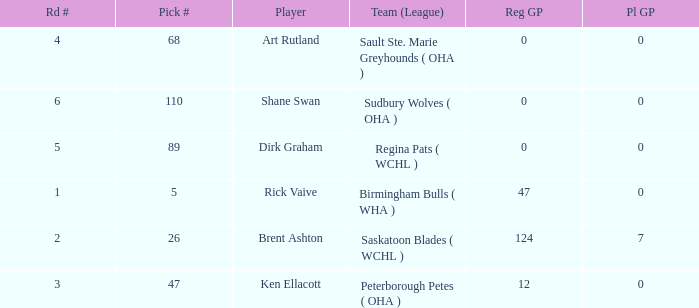How many reg GP for rick vaive in round 1? None. 